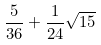<formula> <loc_0><loc_0><loc_500><loc_500>\frac { 5 } { 3 6 } + \frac { 1 } { 2 4 } \sqrt { 1 5 }</formula> 